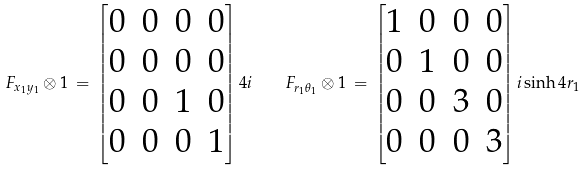<formula> <loc_0><loc_0><loc_500><loc_500>F _ { x _ { 1 } y _ { 1 } } \otimes { 1 } \, = \, \left [ \begin{matrix} 0 & 0 & 0 & 0 \\ 0 & 0 & 0 & 0 \\ 0 & 0 & 1 & 0 \\ 0 & 0 & 0 & 1 \end{matrix} \right ] 4 i \quad F _ { r _ { 1 } \theta _ { 1 } } \otimes { 1 } \, = \, \left [ \begin{matrix} 1 & 0 & 0 & 0 \\ 0 & 1 & 0 & 0 \\ 0 & 0 & 3 & 0 \\ 0 & 0 & 0 & 3 \end{matrix} \right ] i \sinh 4 r _ { 1 }</formula> 